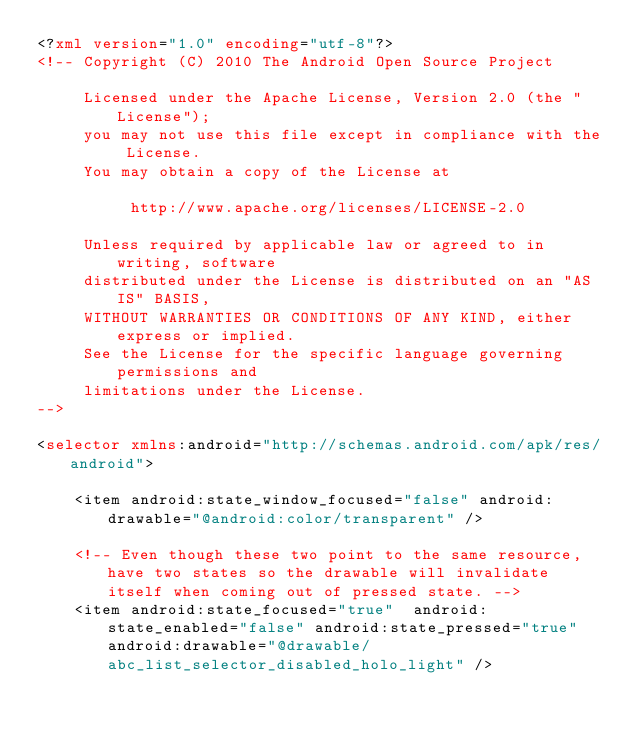Convert code to text. <code><loc_0><loc_0><loc_500><loc_500><_XML_><?xml version="1.0" encoding="utf-8"?>
<!-- Copyright (C) 2010 The Android Open Source Project

     Licensed under the Apache License, Version 2.0 (the "License");
     you may not use this file except in compliance with the License.
     You may obtain a copy of the License at

          http://www.apache.org/licenses/LICENSE-2.0

     Unless required by applicable law or agreed to in writing, software
     distributed under the License is distributed on an "AS IS" BASIS,
     WITHOUT WARRANTIES OR CONDITIONS OF ANY KIND, either express or implied.
     See the License for the specific language governing permissions and
     limitations under the License.
-->

<selector xmlns:android="http://schemas.android.com/apk/res/android">

    <item android:state_window_focused="false" android:drawable="@android:color/transparent" />

    <!-- Even though these two point to the same resource, have two states so the drawable will invalidate itself when coming out of pressed state. -->
    <item android:state_focused="true"  android:state_enabled="false" android:state_pressed="true" android:drawable="@drawable/abc_list_selector_disabled_holo_light" /></code> 